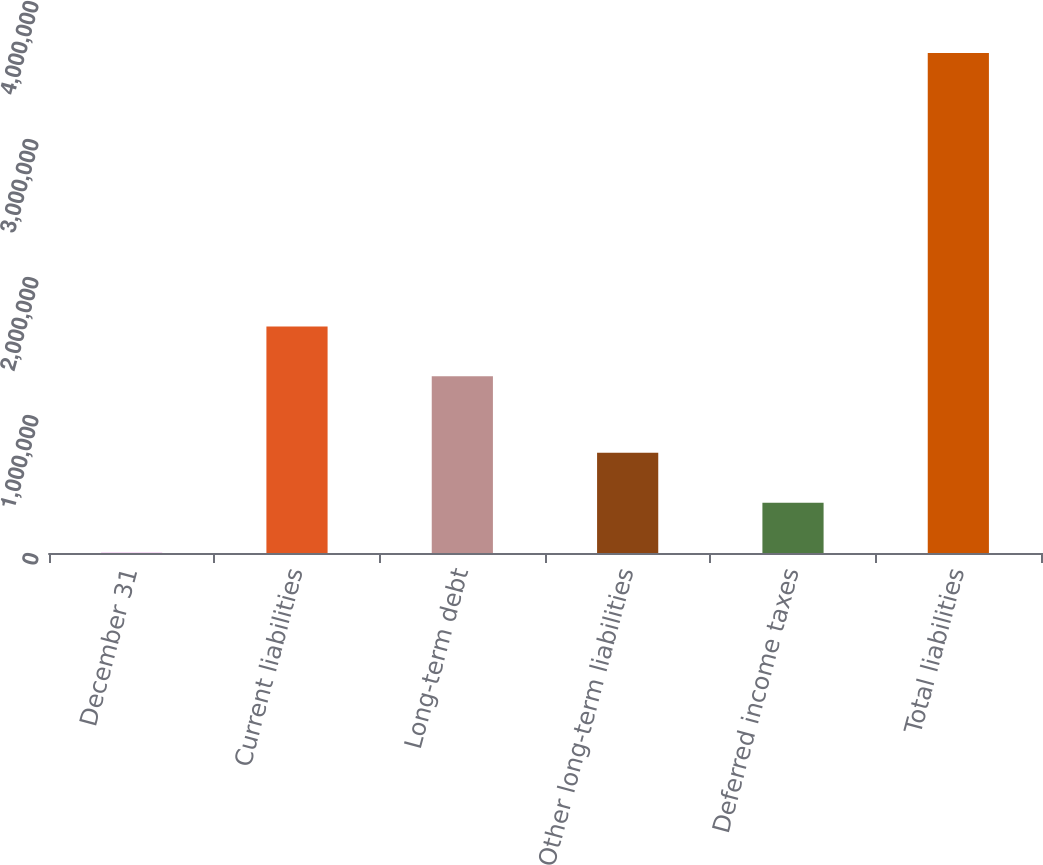<chart> <loc_0><loc_0><loc_500><loc_500><bar_chart><fcel>December 31<fcel>Current liabilities<fcel>Long-term debt<fcel>Other long-term liabilities<fcel>Deferred income taxes<fcel>Total liabilities<nl><fcel>2007<fcel>1.64212e+06<fcel>1.27996e+06<fcel>726324<fcel>364166<fcel>3.62359e+06<nl></chart> 